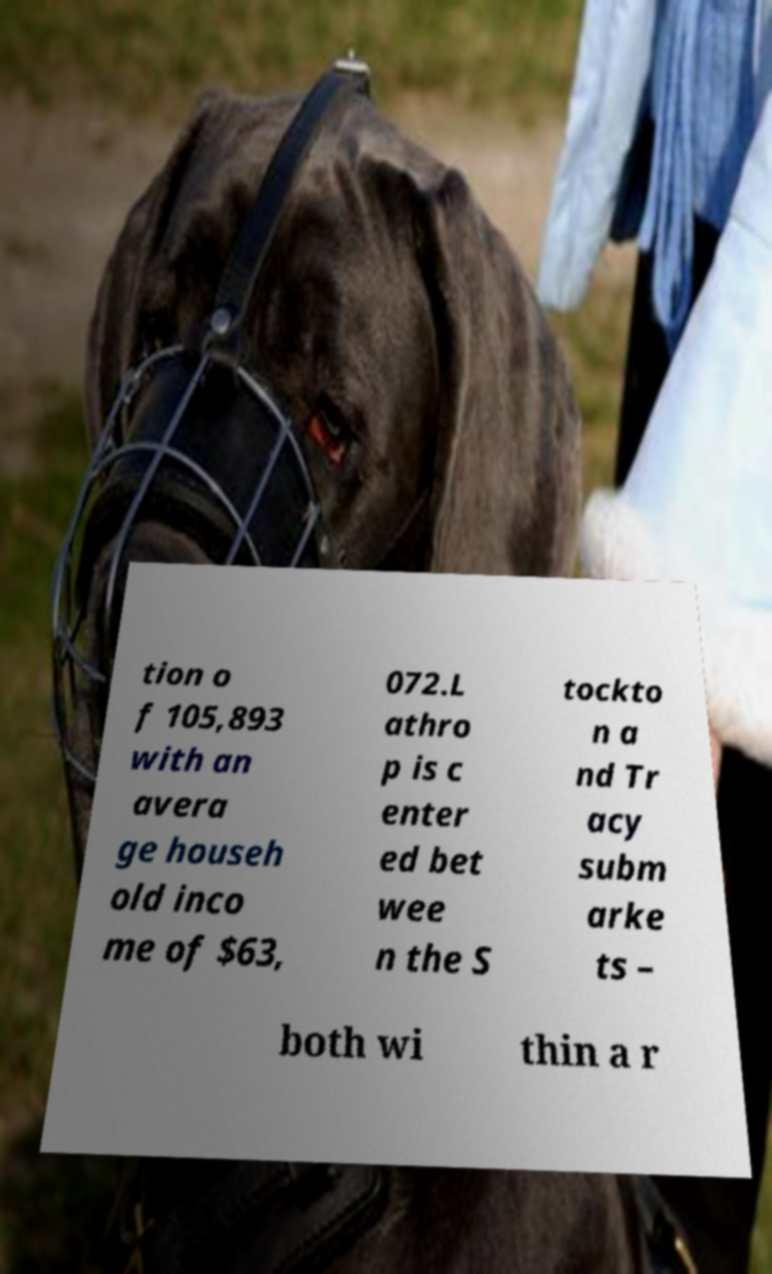Please identify and transcribe the text found in this image. tion o f 105,893 with an avera ge househ old inco me of $63, 072.L athro p is c enter ed bet wee n the S tockto n a nd Tr acy subm arke ts – both wi thin a r 